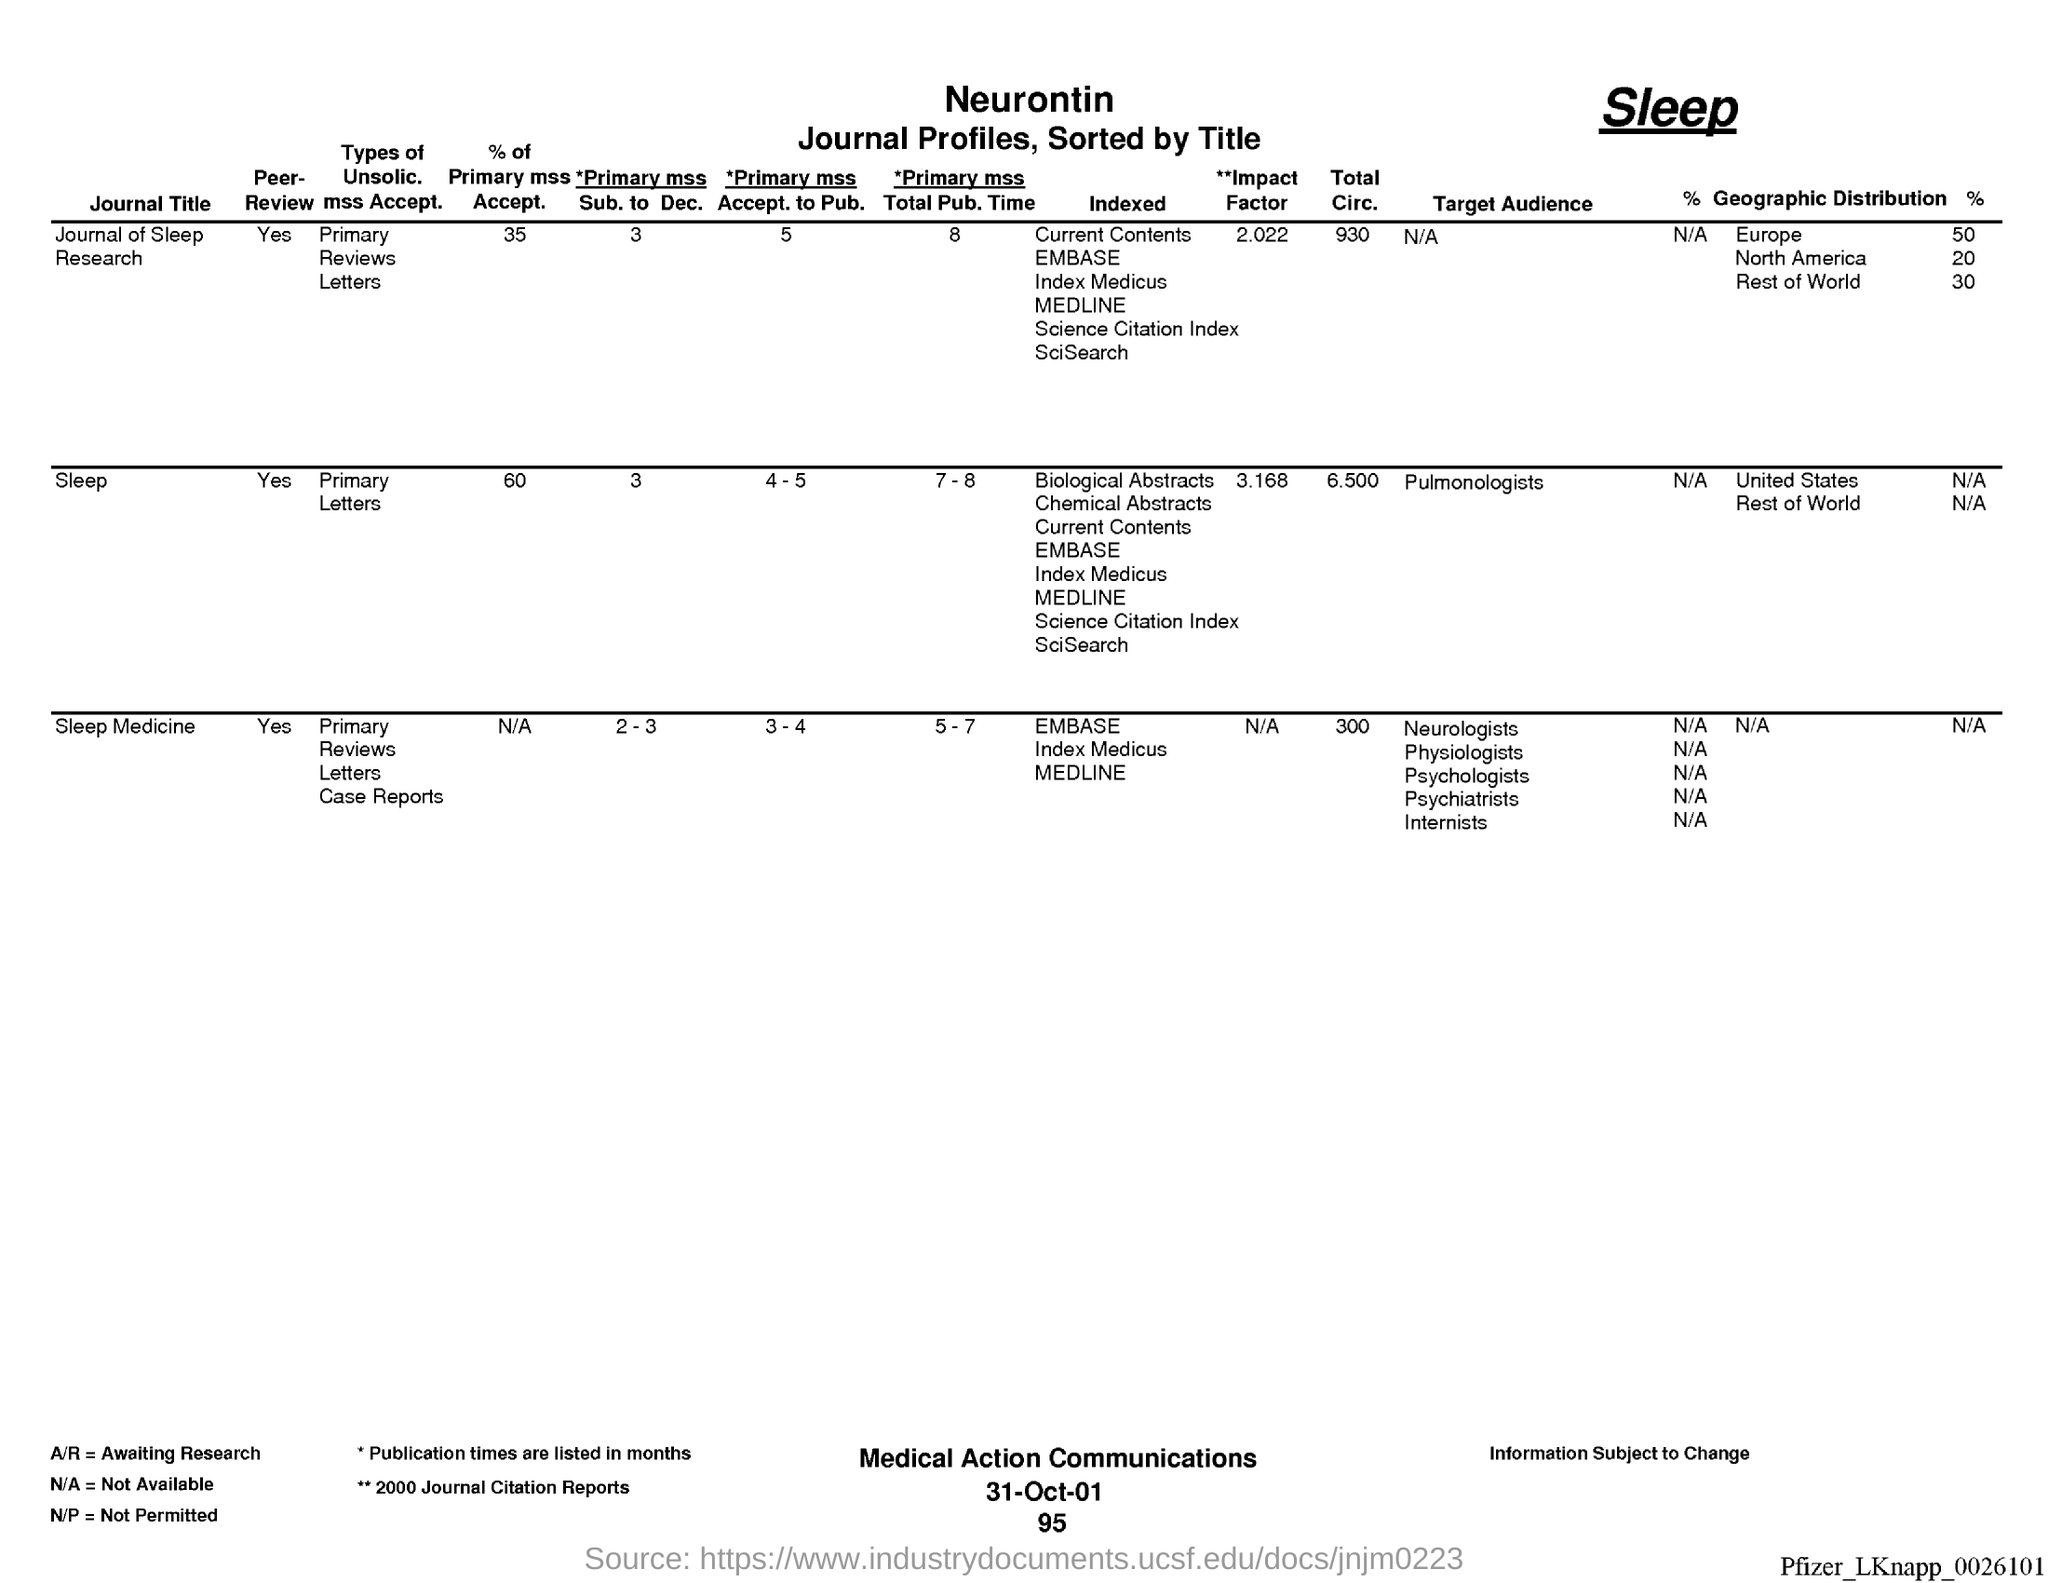What is the % of Primary mss Accept. for Journal of sleep Research?
Offer a very short reply. 35. What is the % of Primary mss Accept. for Sleep?
Your answer should be very brief. 60. What is the % of Primary mss Accept. for Sleep Medicine?
Keep it short and to the point. N/A. What is the Primary mss Sub. to Dec. for Journal of sleep Research?
Provide a succinct answer. 3. What is the Primary mss Sub. to Dec. for sleep?
Your response must be concise. 3. What is the Primary mss Sub. to Dec. for sleep medicine?
Provide a short and direct response. 2-3. What is the Primary mss Accept. to Pub. for Journal of sleep Research?
Give a very brief answer. 5. What is the Primary mss Accept. to Pub. for Sleep?
Make the answer very short. 4-5. What is the Primary mss Accept. to Pub. for Sleep medicine?
Your answer should be very brief. 3-4. What is the date on the document?
Ensure brevity in your answer.  31-Oct-01. 